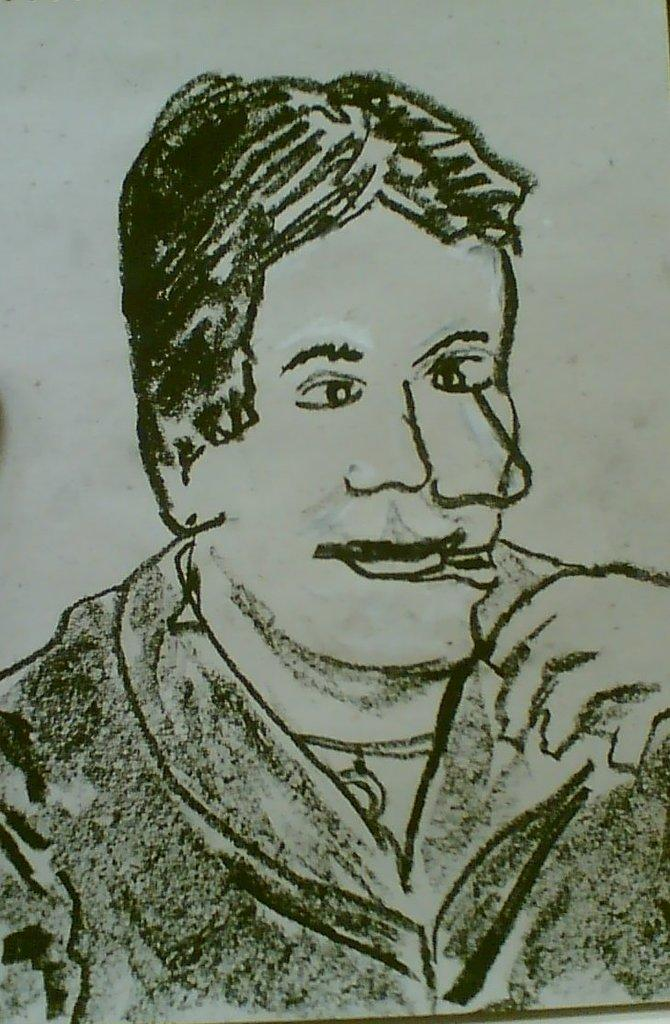What is depicted in the image? There is a drawing of a person in the image. What type of cough medicine is recommended for the person in the drawing? There is no cough medicine or any indication of a cough in the image; it only features a drawing of a person. 